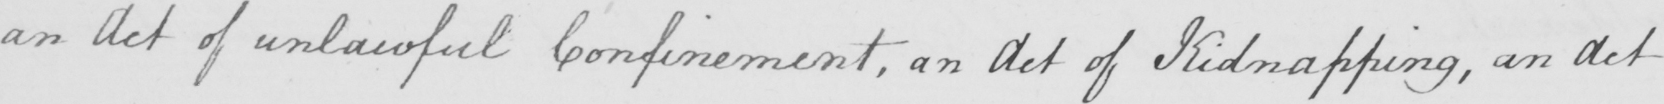Can you read and transcribe this handwriting? an Act of unlawful Confinement , an Act of Kidnapping , an Act 